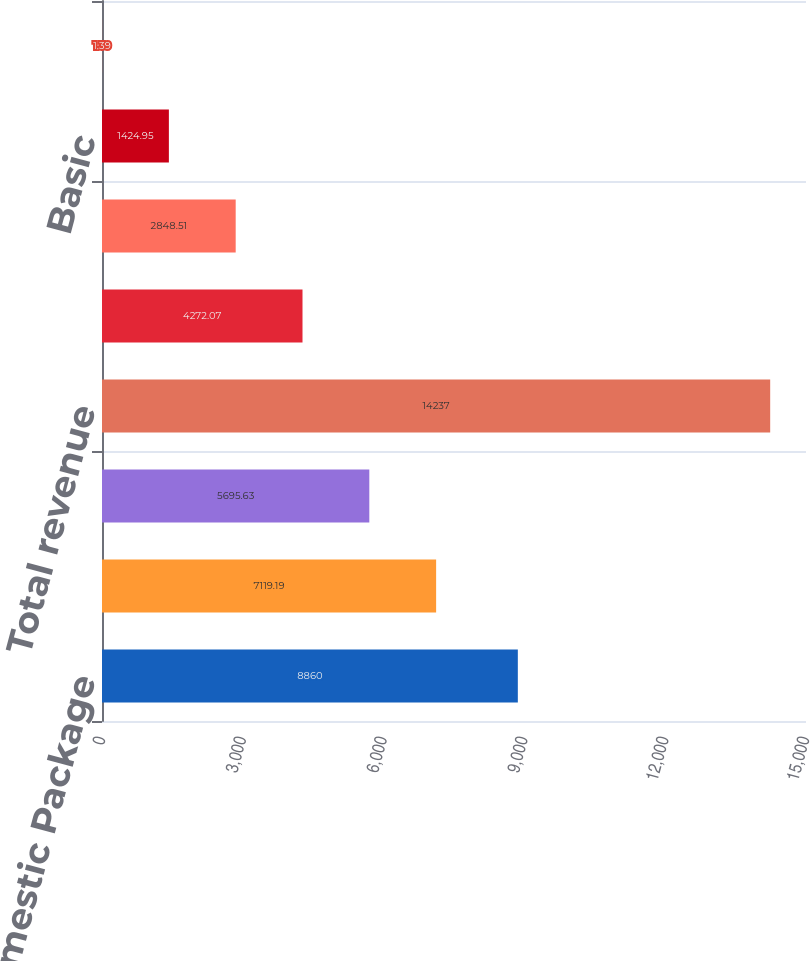<chart> <loc_0><loc_0><loc_500><loc_500><bar_chart><fcel>US Domestic Package<fcel>International Package<fcel>Supply Chain & Freight<fcel>Total revenue<fcel>Total operating profit<fcel>Net Income<fcel>Basic<fcel>Diluted<nl><fcel>8860<fcel>7119.19<fcel>5695.63<fcel>14237<fcel>4272.07<fcel>2848.51<fcel>1424.95<fcel>1.39<nl></chart> 